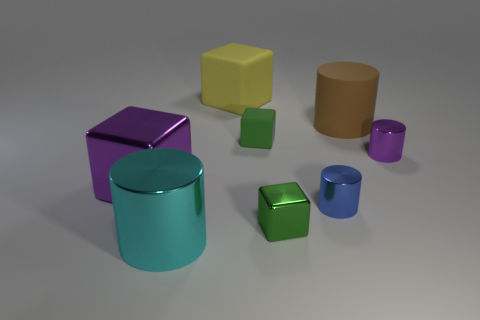Add 2 metallic cylinders. How many objects exist? 10 Subtract all metallic cylinders. How many cylinders are left? 1 Subtract 2 cubes. How many cubes are left? 2 Add 1 objects. How many objects are left? 9 Add 5 big brown objects. How many big brown objects exist? 6 Subtract all yellow cubes. How many cubes are left? 3 Subtract 0 red cylinders. How many objects are left? 8 Subtract all brown cylinders. Subtract all gray cubes. How many cylinders are left? 3 Subtract all green spheres. How many cyan cubes are left? 0 Subtract all small purple things. Subtract all big rubber blocks. How many objects are left? 6 